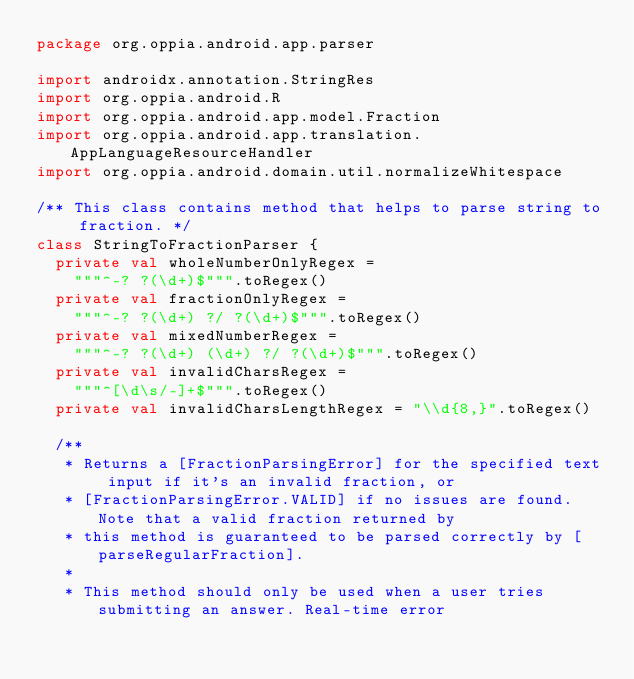Convert code to text. <code><loc_0><loc_0><loc_500><loc_500><_Kotlin_>package org.oppia.android.app.parser

import androidx.annotation.StringRes
import org.oppia.android.R
import org.oppia.android.app.model.Fraction
import org.oppia.android.app.translation.AppLanguageResourceHandler
import org.oppia.android.domain.util.normalizeWhitespace

/** This class contains method that helps to parse string to fraction. */
class StringToFractionParser {
  private val wholeNumberOnlyRegex =
    """^-? ?(\d+)$""".toRegex()
  private val fractionOnlyRegex =
    """^-? ?(\d+) ?/ ?(\d+)$""".toRegex()
  private val mixedNumberRegex =
    """^-? ?(\d+) (\d+) ?/ ?(\d+)$""".toRegex()
  private val invalidCharsRegex =
    """^[\d\s/-]+$""".toRegex()
  private val invalidCharsLengthRegex = "\\d{8,}".toRegex()

  /**
   * Returns a [FractionParsingError] for the specified text input if it's an invalid fraction, or
   * [FractionParsingError.VALID] if no issues are found. Note that a valid fraction returned by
   * this method is guaranteed to be parsed correctly by [parseRegularFraction].
   *
   * This method should only be used when a user tries submitting an answer. Real-time error</code> 